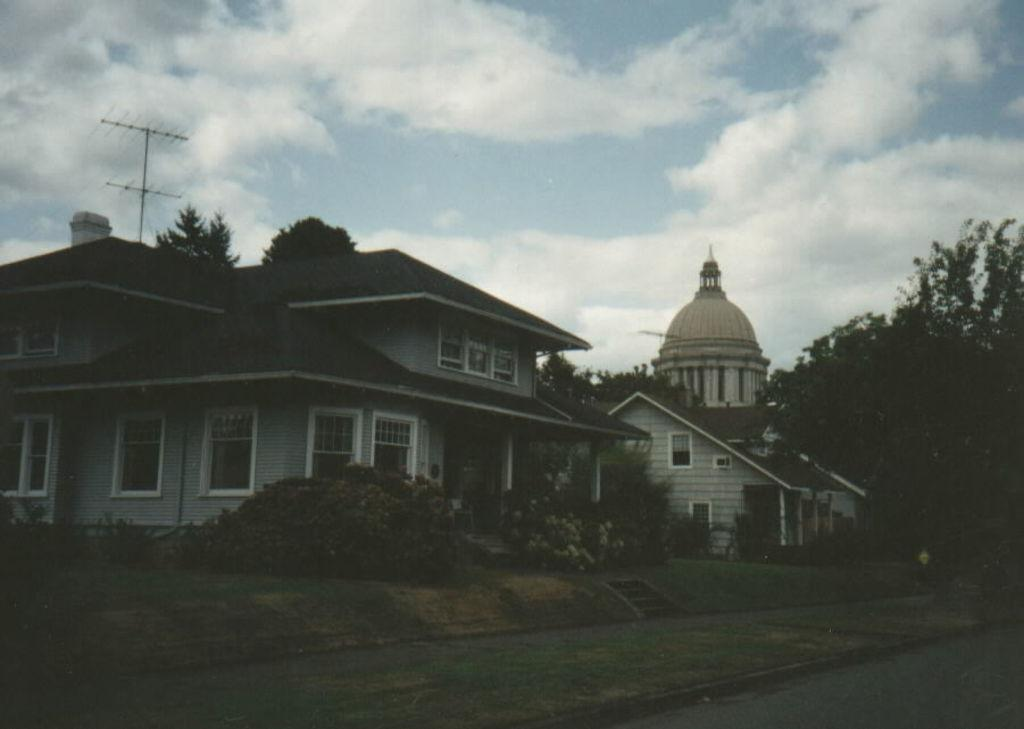What type of structures can be seen in the image? There are buildings in the image. What other natural elements are present in the image? There are trees in the image. What can be seen in the background of the image? There are clouds visible in the background of the image. How many ants can be seen carrying food on the buildings in the image? There are no ants visible in the image, and therefore no such activity can be observed. 